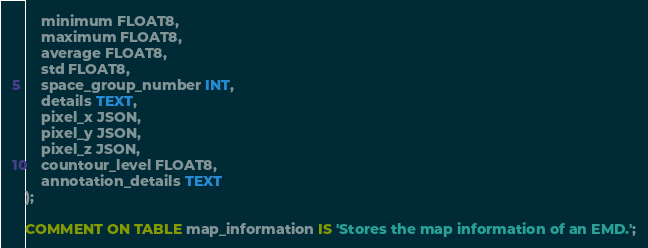<code> <loc_0><loc_0><loc_500><loc_500><_SQL_>	minimum FLOAT8,
	maximum FLOAT8,
	average FLOAT8,
	std FLOAT8,
	space_group_number INT,
	details TEXT,
	pixel_x JSON,
	pixel_y JSON,
	pixel_z JSON,
	countour_level FLOAT8,
	annotation_details TEXT
);

COMMENT ON TABLE map_information IS 'Stores the map information of an EMD.';
</code> 